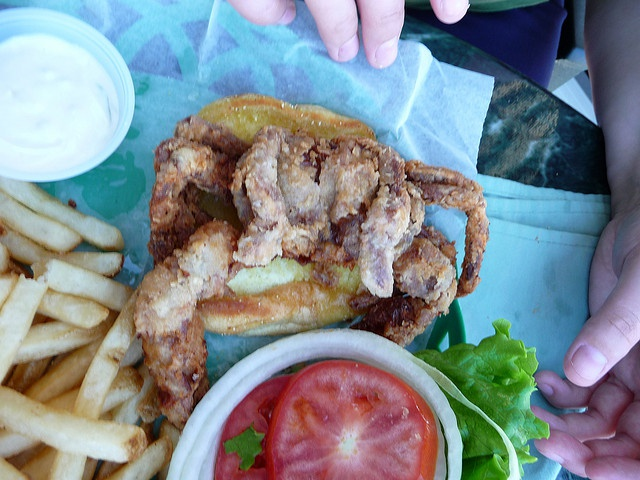Describe the objects in this image and their specific colors. I can see sandwich in lightblue, darkgray, gray, tan, and maroon tones, people in lightblue, gray, lavender, navy, and black tones, bowl in lightblue and teal tones, and broccoli in lightblue, darkgreen, and green tones in this image. 